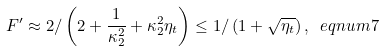Convert formula to latex. <formula><loc_0><loc_0><loc_500><loc_500>F ^ { \prime } \approx 2 / \left ( 2 + \frac { 1 } { \kappa _ { 2 } ^ { 2 } } + \kappa _ { 2 } ^ { 2 } \eta _ { t } \right ) \leq 1 / \left ( 1 + \sqrt { \eta _ { t } } \right ) , \ e q n u m { 7 }</formula> 